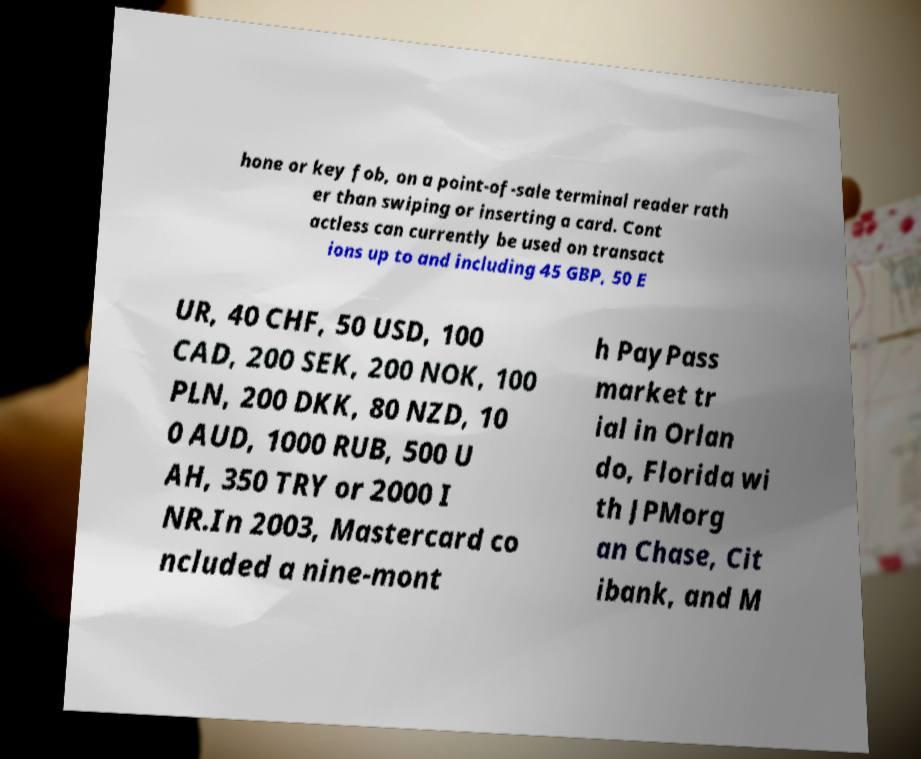What messages or text are displayed in this image? I need them in a readable, typed format. hone or key fob, on a point-of-sale terminal reader rath er than swiping or inserting a card. Cont actless can currently be used on transact ions up to and including 45 GBP, 50 E UR, 40 CHF, 50 USD, 100 CAD, 200 SEK, 200 NOK, 100 PLN, 200 DKK, 80 NZD, 10 0 AUD, 1000 RUB, 500 U AH, 350 TRY or 2000 I NR.In 2003, Mastercard co ncluded a nine-mont h PayPass market tr ial in Orlan do, Florida wi th JPMorg an Chase, Cit ibank, and M 